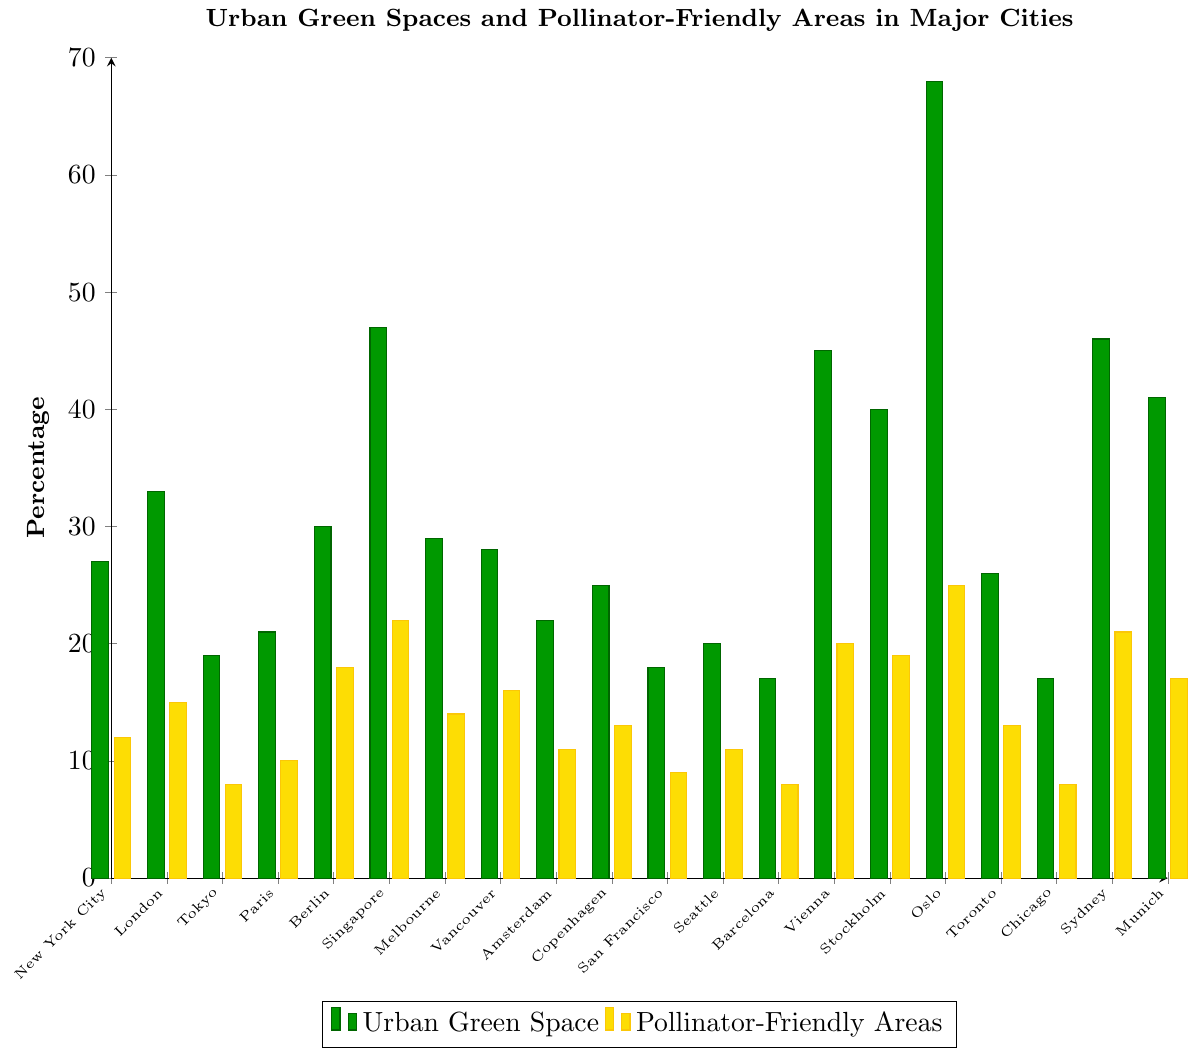Which city has the highest percentage of urban green space? By visually inspecting the height of the green bar for each city, Oslo has the highest green bar representing urban green space.
Answer: Oslo Which city has a higher percentage of pollinator-friendly areas, Berlin or Munich? By comparing the height of the yellow bars for Berlin and Munich, Berlin's yellow bar is higher.
Answer: Berlin What is the difference in percentage of urban green space between Singapore and Tokyo? By finding the height of the green bars for Singapore (47) and Tokyo (19), we can subtract Tokyo's value from Singapore's value, i.e., 47 - 19.
Answer: 28 Which city has the lowest percentage of pollinator-friendly areas? By inspecting the yellow bars for each city, Tokyo, Barcelona, and Chicago have the lowest yellow bars at 8%.
Answer: Tokyo, Barcelona, Chicago What is the average percentage of pollinator-friendly areas in New York City, London, and Paris? Adding the percentages of pollinator-friendly areas in New York City (12), London (15), and Paris (10), then dividing by 3 gives (12 + 15 + 10) / 3.
Answer: 12.33 Does any city have more pollinator-friendly areas than urban green space? By comparing the height of the green and yellow bars for each city, no city has a higher yellow bar (pollinator-friendly areas) than the green bar (urban green space).
Answer: No Compare the percentage of urban green space between cities with at least 40% green space. Oslo (68%), Vienna (45%), Stockholm (40%), Sydney (46%), Singapore (47%), Munich (41%). Oslo has the highest percentage among these.
Answer: Oslo What is the percentage difference in pollinator-friendly areas between the city with the highest and the lowest values? Oslo has the highest pollinator-friendly areas (25%), and Tokyo, Barcelona, and Chicago have the lowest (8%), so the difference is 25 - 8.
Answer: 17 Among the cities with more than 30% urban green space, which ones also have more than 15% pollinator-friendly areas? Cities with more than 30% green space are London (33%), Berlin (30%), Singapore (47%), Vienna (45%), Stockholm (40%), Oslo (68%), Sydney (46%), Munich (41%), all of which have more than 15% pollinator-friendly areas except Berlin (18), Vienna (20), Stockholm (19), Oslo (25), Sydney (21), Munich (17). London and Singapore also fit this criterion.
Answer: London, Singapore 